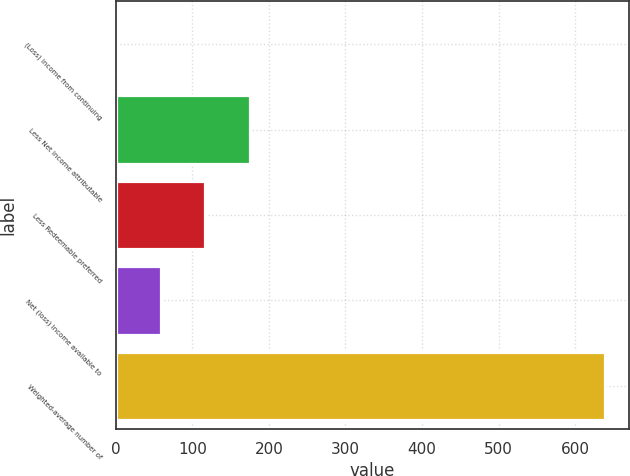Convert chart. <chart><loc_0><loc_0><loc_500><loc_500><bar_chart><fcel>(Loss) income from continuing<fcel>Less Net income attributable<fcel>Less Redeemable preferred<fcel>Net (loss) income available to<fcel>Weighted-average number of<nl><fcel>0.28<fcel>174.94<fcel>116.72<fcel>58.5<fcel>638.82<nl></chart> 